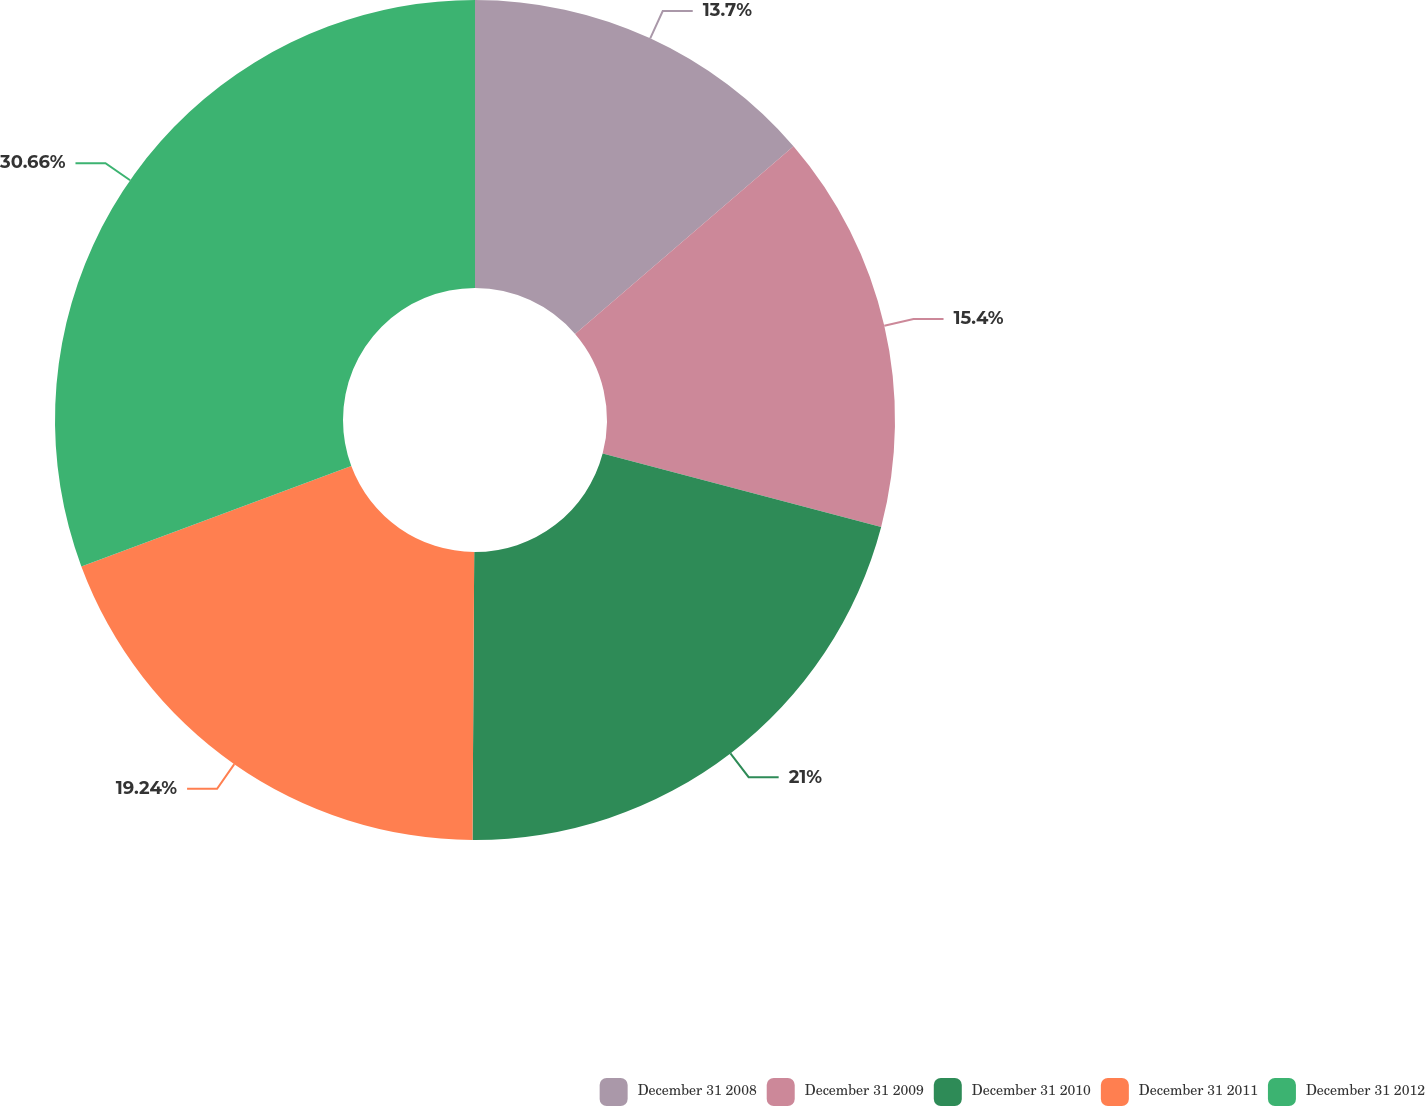Convert chart. <chart><loc_0><loc_0><loc_500><loc_500><pie_chart><fcel>December 31 2008<fcel>December 31 2009<fcel>December 31 2010<fcel>December 31 2011<fcel>December 31 2012<nl><fcel>13.7%<fcel>15.4%<fcel>21.0%<fcel>19.24%<fcel>30.67%<nl></chart> 